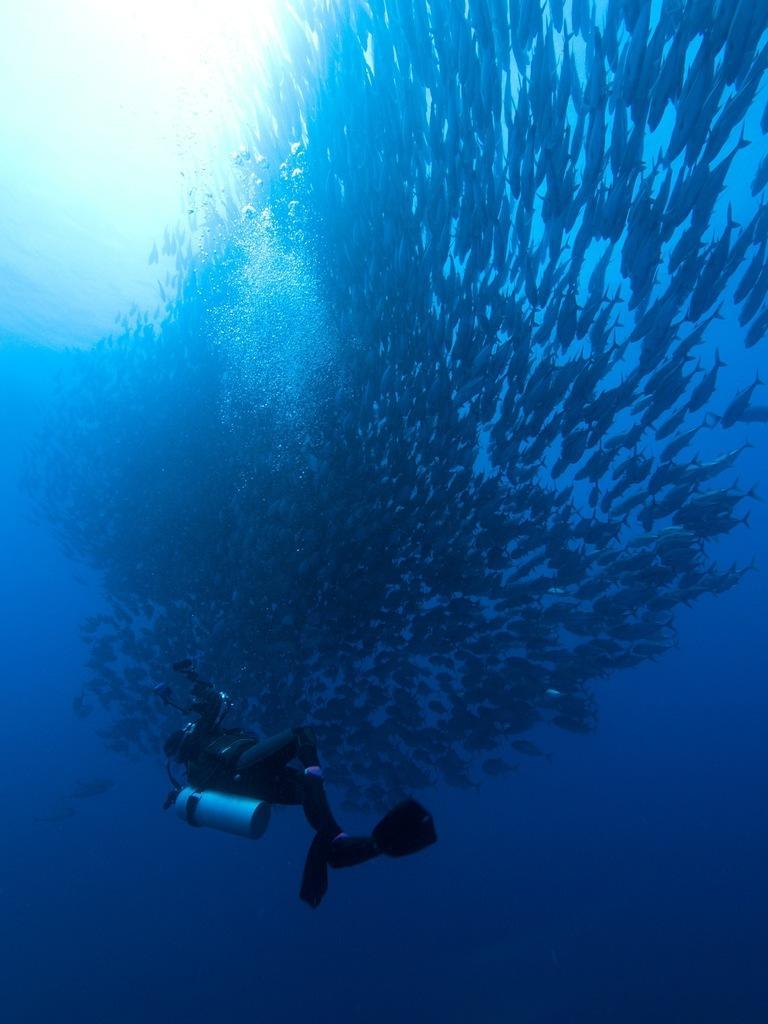Can you describe this image briefly? In this picture we can see an underwater environment, there is a person swimming in the water, we can also see fishes, this person is carrying a cylinder. 